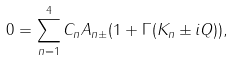Convert formula to latex. <formula><loc_0><loc_0><loc_500><loc_500>0 = \sum _ { n = 1 } ^ { 4 } C _ { n } A _ { n \pm } ( 1 + \Gamma ( K _ { n } \pm i Q ) ) ,</formula> 